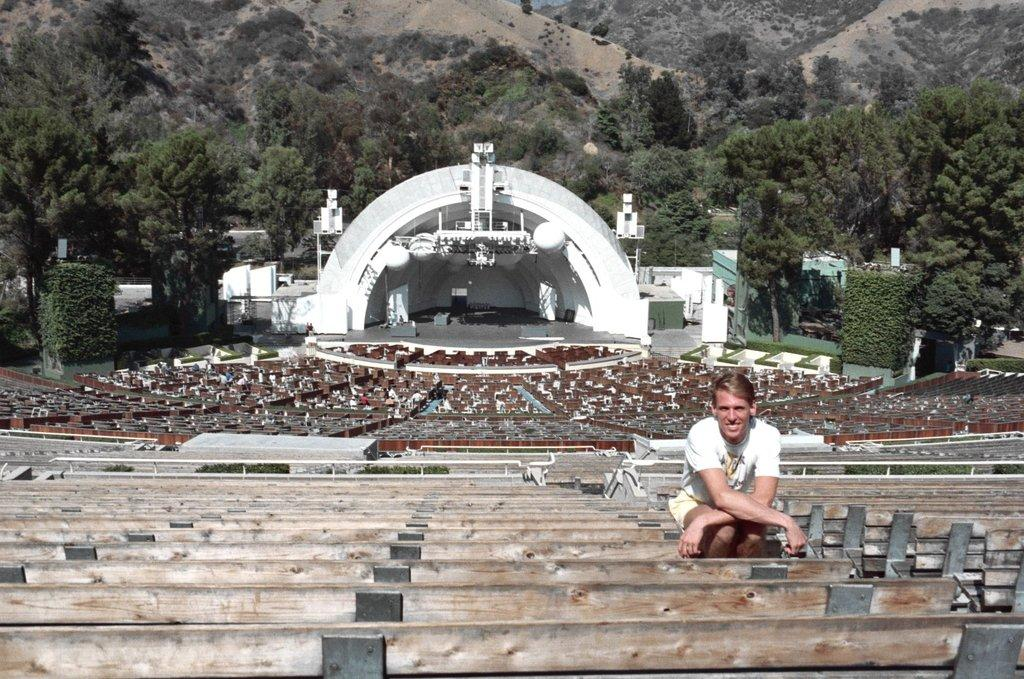What is the man in the image doing? The man is sitting on a bench in the image. What can be seen in the background behind the man? There are trees, additional benches, a stage, and mountains in the background. What is the man's reaction to the riddle being solved on the stage in the image? There is no indication of a riddle or the man's reaction to it in the image. 